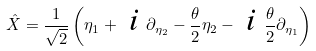Convert formula to latex. <formula><loc_0><loc_0><loc_500><loc_500>\hat { X } = \frac { 1 } { \sqrt { 2 } } \left ( \eta _ { 1 } + \emph { i } \partial _ { \eta _ { 2 } } - \frac { \theta } { 2 } \eta _ { 2 } - \emph { i } \frac { \theta } { 2 } \partial _ { \eta _ { 1 } } \right )</formula> 